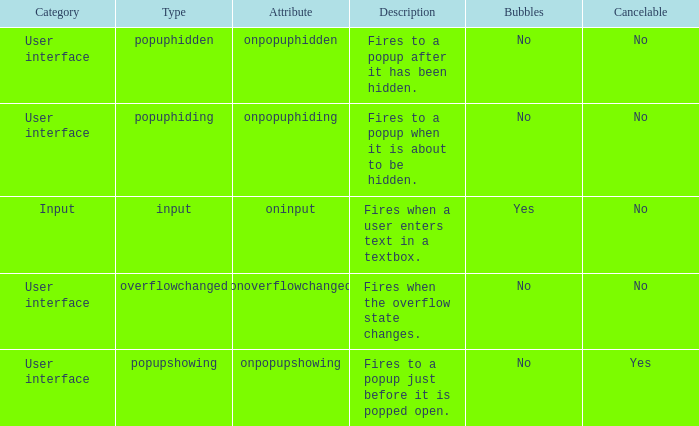What's the cancelable with bubbles being yes No. 